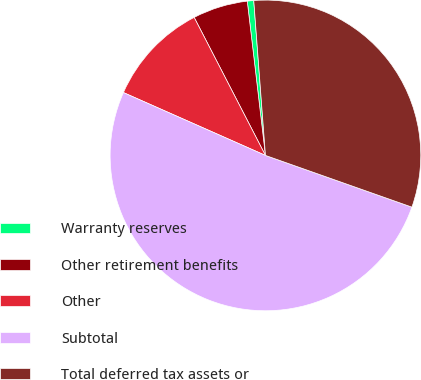Convert chart to OTSL. <chart><loc_0><loc_0><loc_500><loc_500><pie_chart><fcel>Warranty reserves<fcel>Other retirement benefits<fcel>Other<fcel>Subtotal<fcel>Total deferred tax assets or<nl><fcel>0.67%<fcel>5.72%<fcel>10.78%<fcel>51.23%<fcel>31.6%<nl></chart> 